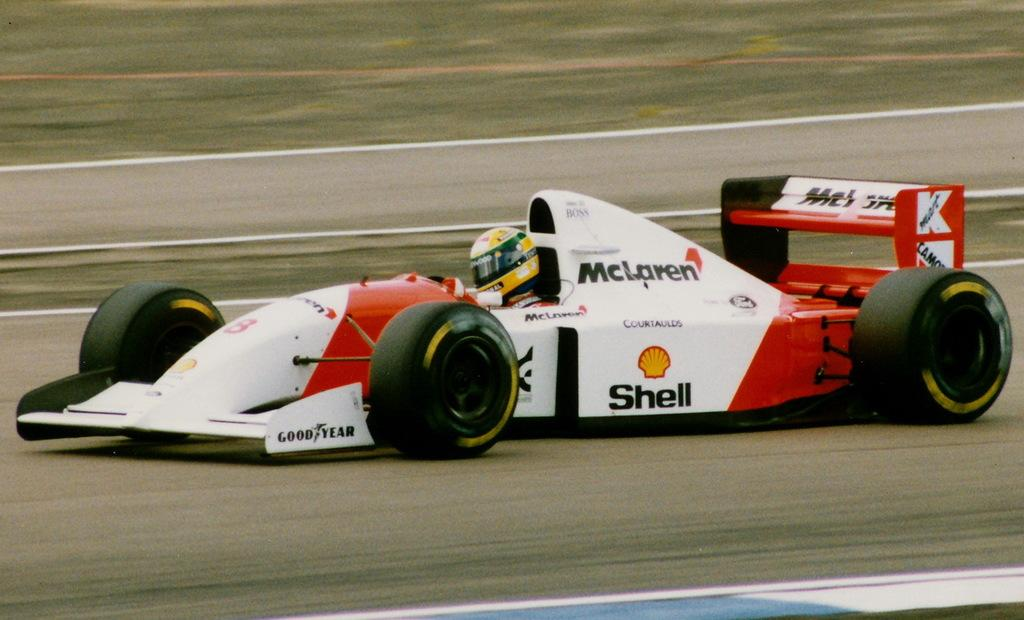<image>
Describe the image concisely. A race car that is sponsored by McLaren, Shell and Goodyear speeds around the track. 